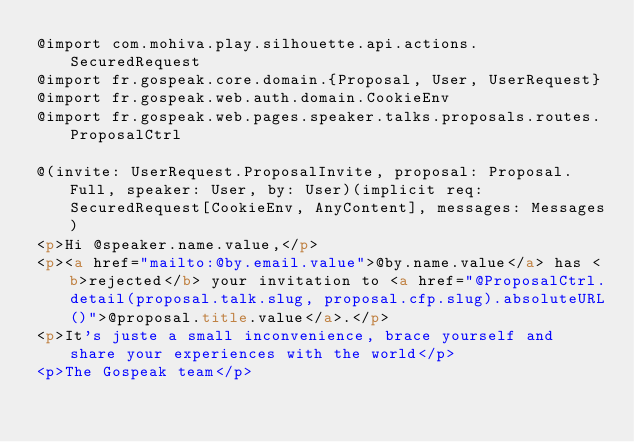Convert code to text. <code><loc_0><loc_0><loc_500><loc_500><_HTML_>@import com.mohiva.play.silhouette.api.actions.SecuredRequest
@import fr.gospeak.core.domain.{Proposal, User, UserRequest}
@import fr.gospeak.web.auth.domain.CookieEnv
@import fr.gospeak.web.pages.speaker.talks.proposals.routes.ProposalCtrl

@(invite: UserRequest.ProposalInvite, proposal: Proposal.Full, speaker: User, by: User)(implicit req: SecuredRequest[CookieEnv, AnyContent], messages: Messages)
<p>Hi @speaker.name.value,</p>
<p><a href="mailto:@by.email.value">@by.name.value</a> has <b>rejected</b> your invitation to <a href="@ProposalCtrl.detail(proposal.talk.slug, proposal.cfp.slug).absoluteURL()">@proposal.title.value</a>.</p>
<p>It's juste a small inconvenience, brace yourself and share your experiences with the world</p>
<p>The Gospeak team</p>
</code> 